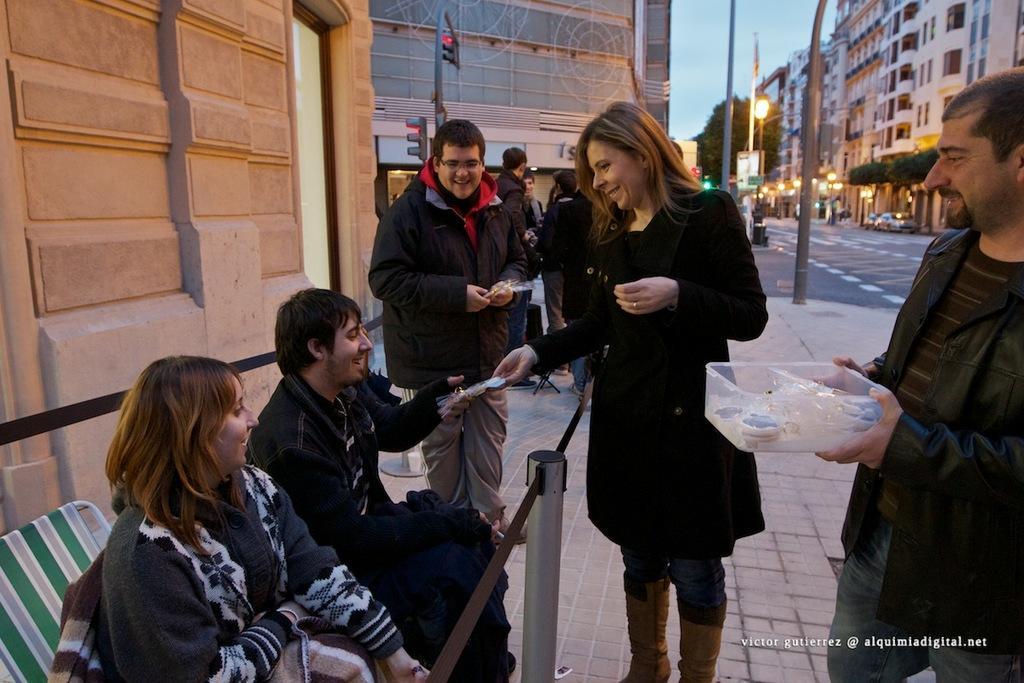Describe this image in one or two sentences. In this image a woman is standing on the pavement. Left side two persons are sitting on the chairs. Beside them there is a person wearing a jacket is standing on the pavement. Right side there is a person standing and he is holding a box in his hand. Few persons are standing on the pavement. Few poles, street lights and trees are on the pavement. Few vehicles are on the road. Background there are few buildings and sky. 